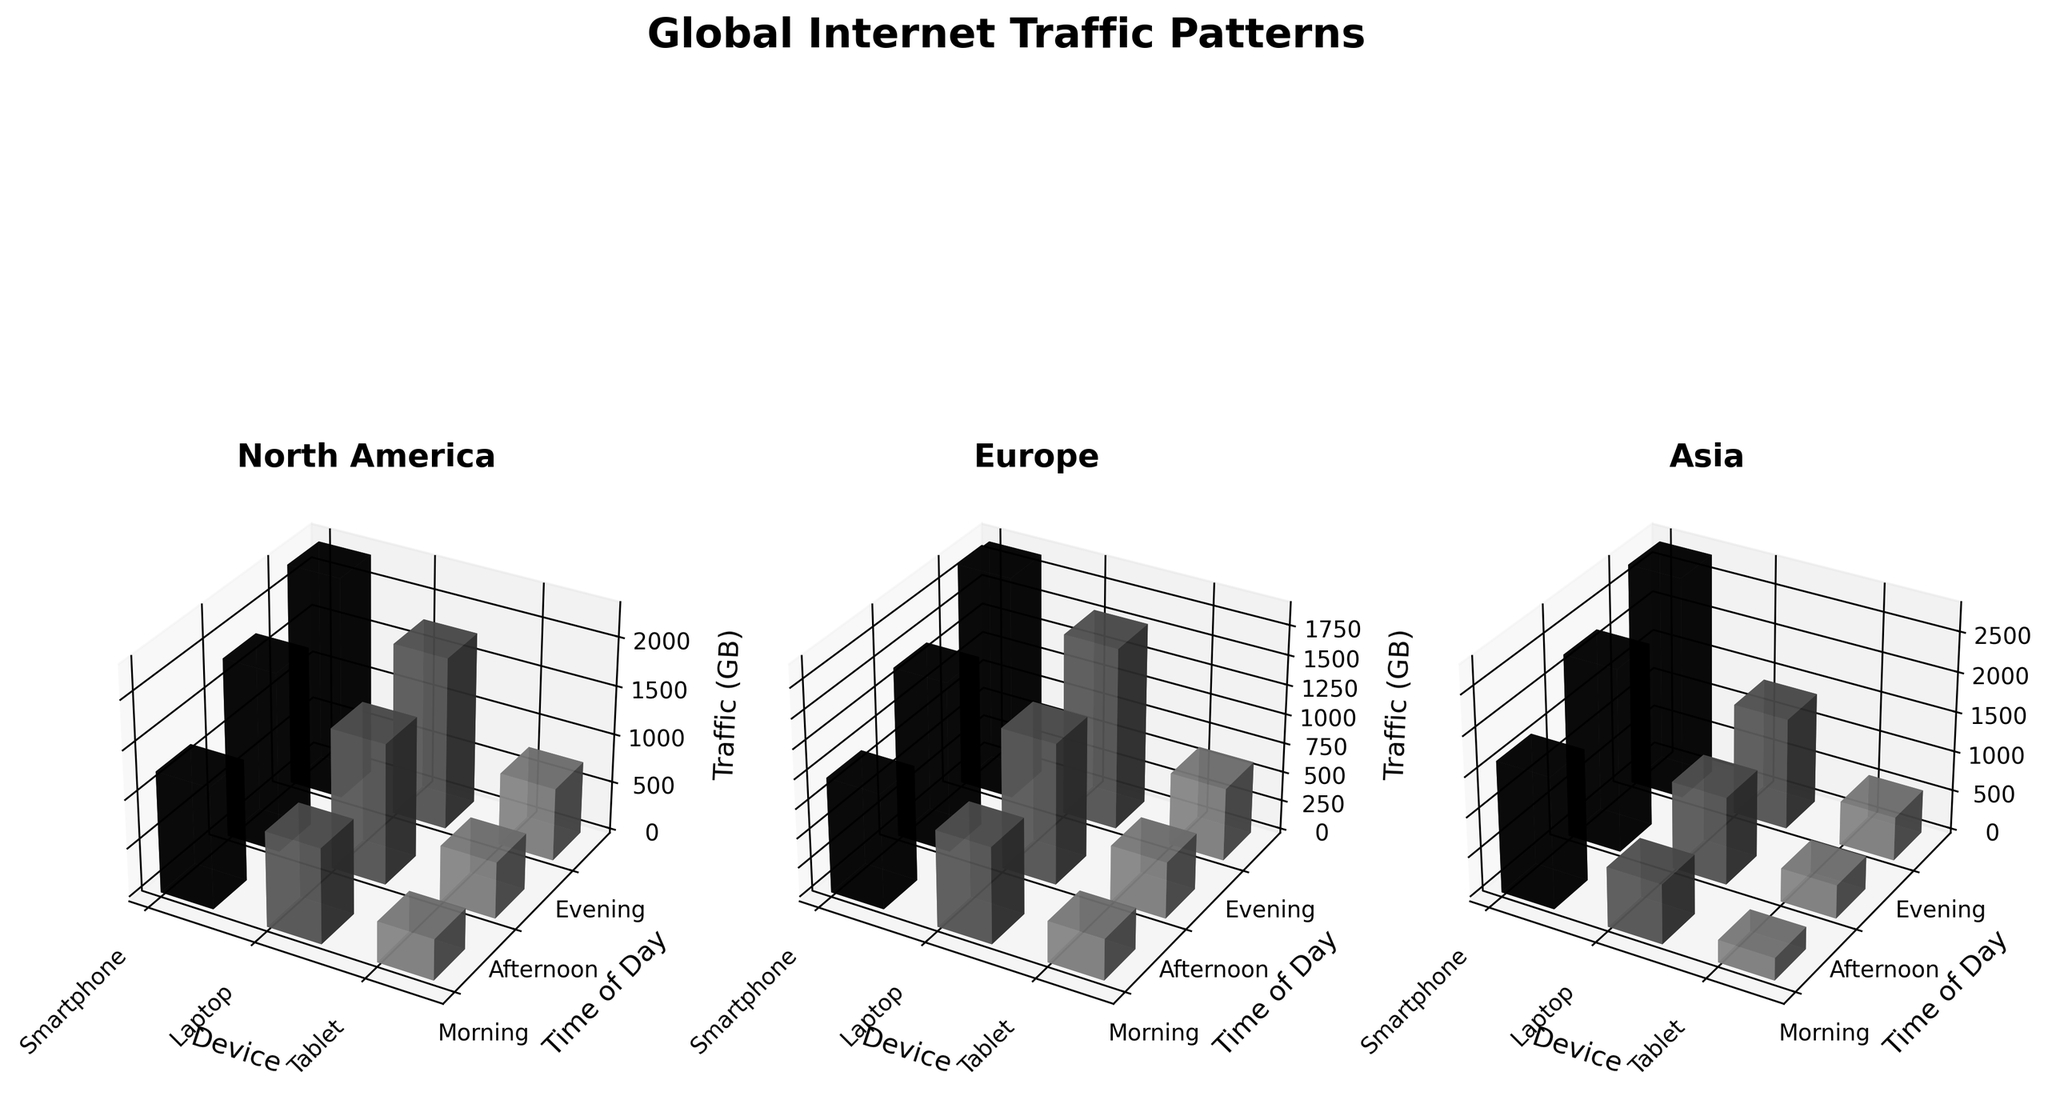What's the title of the figure? The title is typically located at the top of the figure and provides a high-level description of the plot. In this case, it's "Global Internet Traffic Patterns" as visible above the subplots.
Answer: Global Internet Traffic Patterns What are the axes labels for each subplot? For each subplot, the x-axis label is "Device," the y-axis label is "Time of Day," and the z-axis label is "Traffic (GB)." These labels are given in both 2D and 3D plots to explain what each axis represents.
Answer: Device, Time of Day, Traffic (GB) Which region has the highest traffic in the evening for smartphones? By examining the plot and focusing on the evening section for the smartphone bars in each subplot, you can identify that Asia has the highest bar, representing the highest traffic.
Answer: Asia What is the traffic for laptops in North America during the afternoon? Locate the plot for North America, find the afternoon section, and look for the height of the bar for laptops. The label or the bar height indicates the traffic (GB). It's 1450 GB.
Answer: 1450 GB Compare the morning traffic for tablets in Europe and Asia. Which region has greater traffic? Check the morning section for the tablet bars in both the Europe and Asia subplots. Europe has 350 GB while Asia has 280 GB, so Europe has greater traffic.
Answer: Europe What is the total traffic for smartphones in Asia throughout the day? Sum up the traffic values for smartphones in Asia at different times of the day: Morning (1650 GB) + Afternoon (2300 GB) + Evening (2800 GB). So, 1650 + 2300 + 2800 = 6750 GB.
Answer: 6750 GB Which device type in Europe has the lowest traffic in the afternoon? In the Europe subplot, look at the afternoon section and identify the device with the shortest bar. Tablets have the lowest traffic with 480 GB.
Answer: Tablets What is the difference in evening traffic for laptops between North America and Asia? The evening traffic for laptops in North America and Asia can be seen on their respective plots. North America has 1780 GB, and Asia has 1400 GB. The difference is 1780 - 1400 = 380 GB.
Answer: 380 GB What is the COMBINED traffic for tablets in North America in the morning and evening? Add the traffic values for tablets in North America during the morning (420 GB) and evening (750 GB). So, 420 + 750 = 1170 GB.
Answer: 1170 GB 